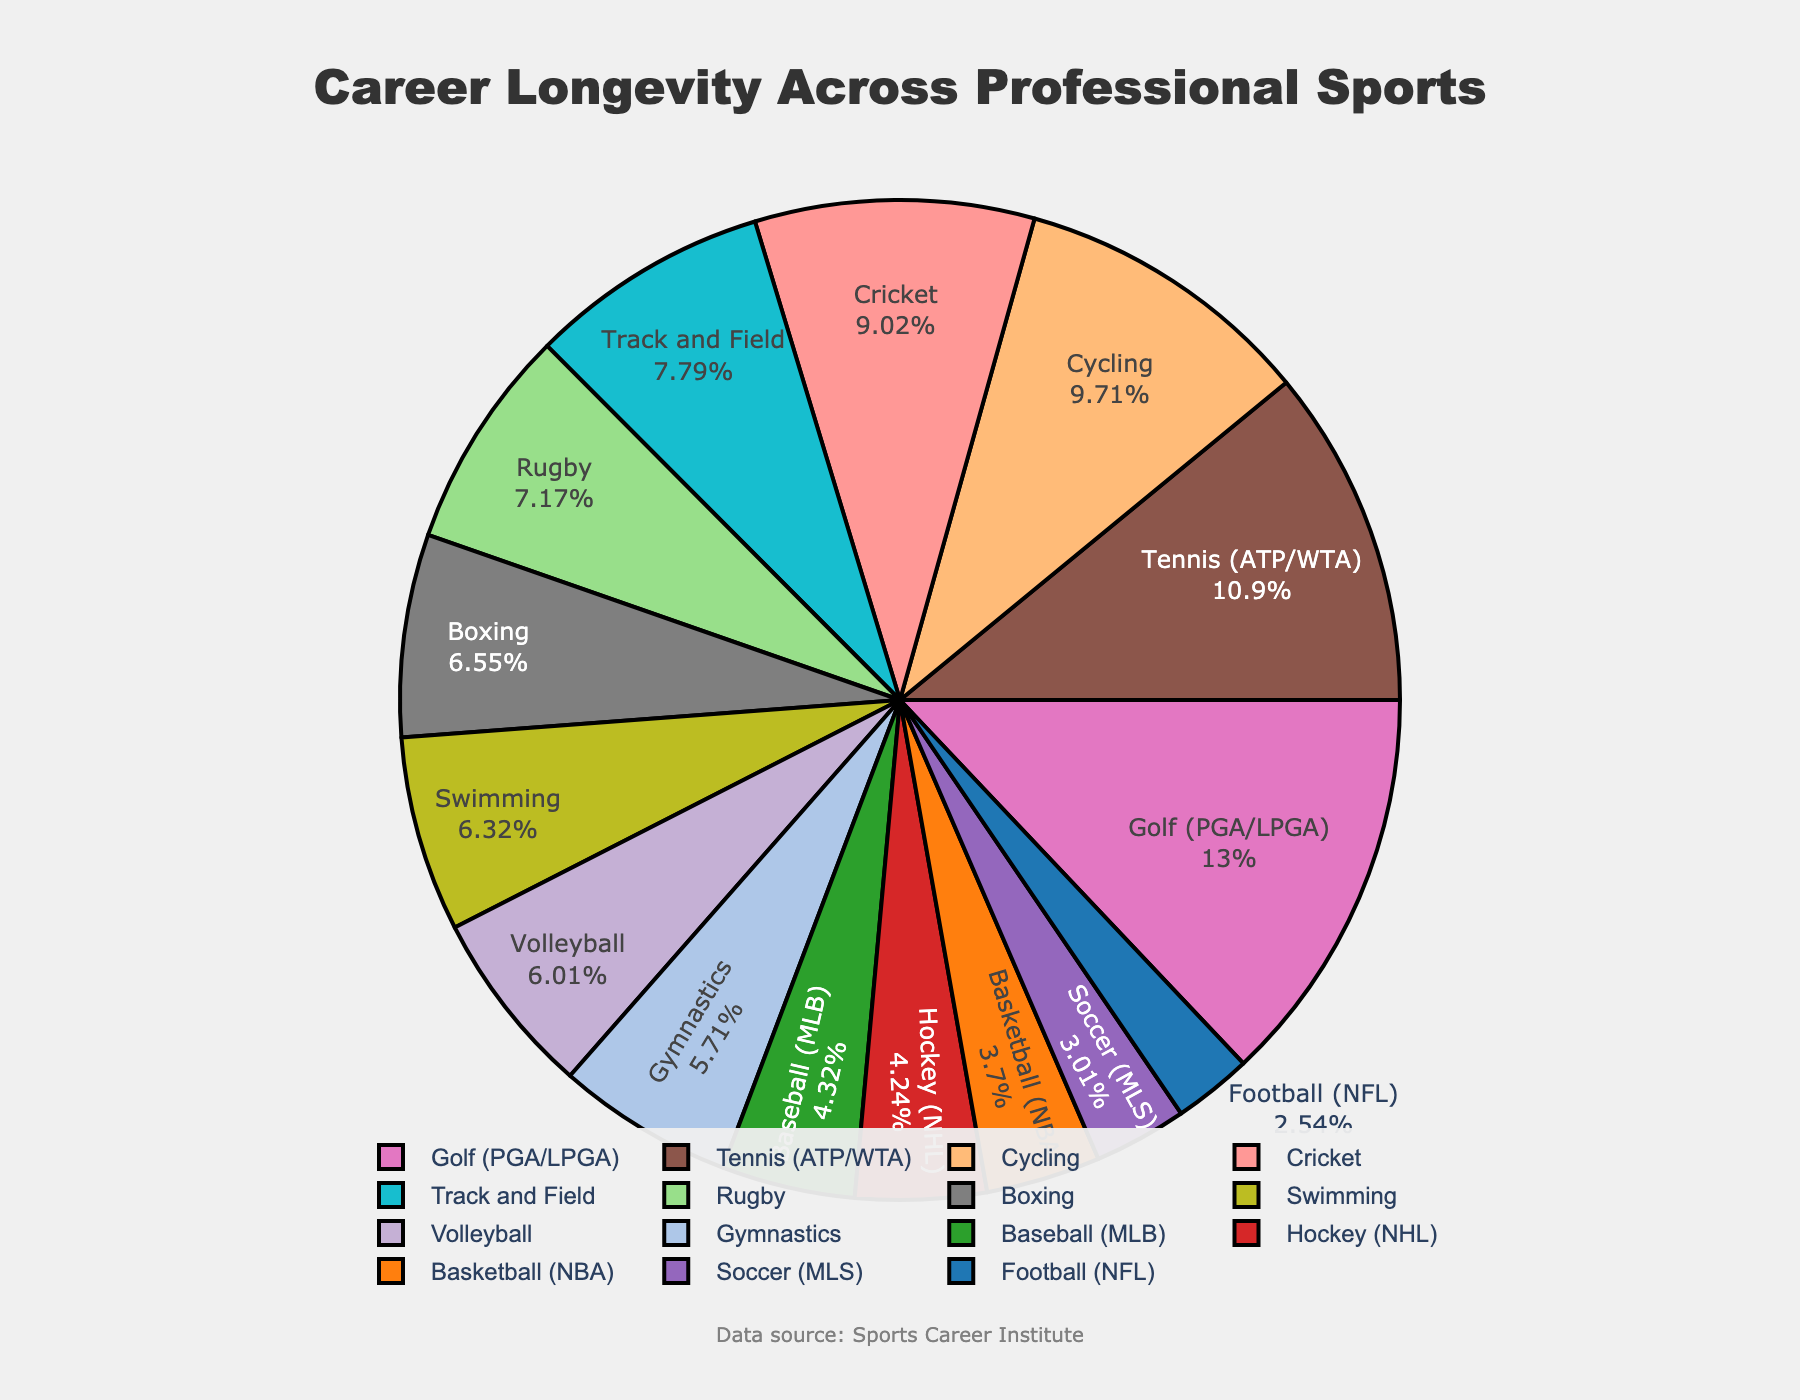Which sport has the longest average career length? The pie chart shows the average career length for various sports, and the largest segment corresponds to Golf with 16.8 years.
Answer: Golf Which sports have an average career length of more than 10 years? The segments representing Tennis, Golf, Track and Field, Cycling, and Cricket show average career lengths of 14.2, 16.8, 10.1, 12.6, and 11.7 years respectively.
Answer: Tennis, Golf, Track and Field, Cycling, Cricket What is the average career length difference between Football and Basketball? The average career length for Football is 3.3 years and for Basketball is 4.8 years. The difference is 4.8 - 3.3 = 1.5 years.
Answer: 1.5 years Which sport has the shortest average career length, and how long is it? The pie chart indicates that Football (NFL) has the shortest average career length of 3.3 years.
Answer: Football (NFL), 3.3 years How does the career duration of Soccer compare to Swimming? As per the chart, Soccer has an average career length of 3.9 years, while Swimming has 8.2 years. Thus, Swimming careers are longer than Soccer by 8.2 - 3.9 = 4.3 years.
Answer: Swimming is longer by 4.3 years List the sports with career lengths between 5 and 10 years. Referring to the visual data, the sports fitting this range are Baseball (5.6 years), Hockey (5.5 years), Gymnastics (7.4 years), Volleyball (7.8 years), and Rugby (9.3 years).
Answer: Baseball, Hockey, Gymnastics, Volleyball, Rugby What is the total average career length for Football, Basketball, and Soccer combined? The chart lists Football at 3.3 years, Basketball at 4.8 years, and Soccer at 3.9 years. Summing these gives 3.3 + 4.8 + 3.9 = 12 years.
Answer: 12 years Which sport has the closest average career length to Gymnastics? From the pie chart, Volleyball has an average career length of 7.8 years, which is closest to Gymnastics' 7.4 years.
Answer: Volleyball 